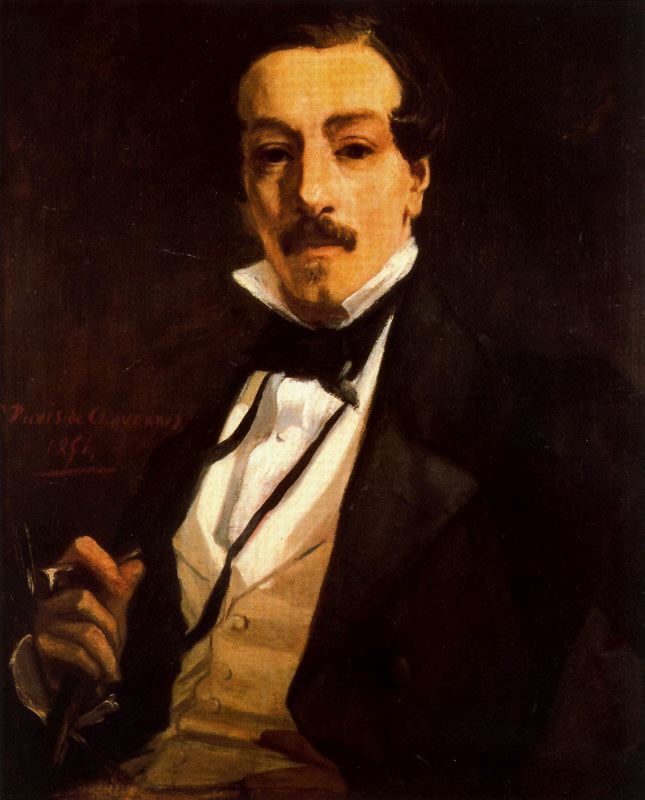Let’s delve into the symbolic meaning of the elements in the portrait. Can you analyze the significance of his clothing and the pen he holds? The formal clothing of the subject—a black suit, white shirt, and black bow tie—symbolizes sophistication, discipline, and status. It highlights the man's societal position and perhaps his meticulous nature. The pen, on the other hand, is a potent symbol of intellectual pursuit, creativity, and communication. Its presence suggests that the man is a writer, scholar, or someone deeply engaged in the world of ideas. The combination of these elements portrays him as a person of refinement and intellect, dedicated to his craft and thoughtful in his actions. The pen held delicately yet firmly indicates that he wields significant power through his words, an instrument through which he shapes thoughts, stories, or historical records. What could the dark background signify in this portrait? The dark background in this portrait adds several layers of meaning. Symbolically, it can represent the unknown or unexplored areas of the subject's mind, highlighting his depth of thought and introspection. The stark contrast it creates with the subject's lighter clothing draws the viewer's eye to him, emphasizing his importance and the seriousness of his endeavor. Additionally, the dark hues lend a somber, almost contemplative mood to the piece, suggesting that the man is engaged in a profound and possibly solitary pursuit. It serves to isolate him from any distractions, creating an intimate space that invites the viewer to focus solely on the man and his expression of thought. 